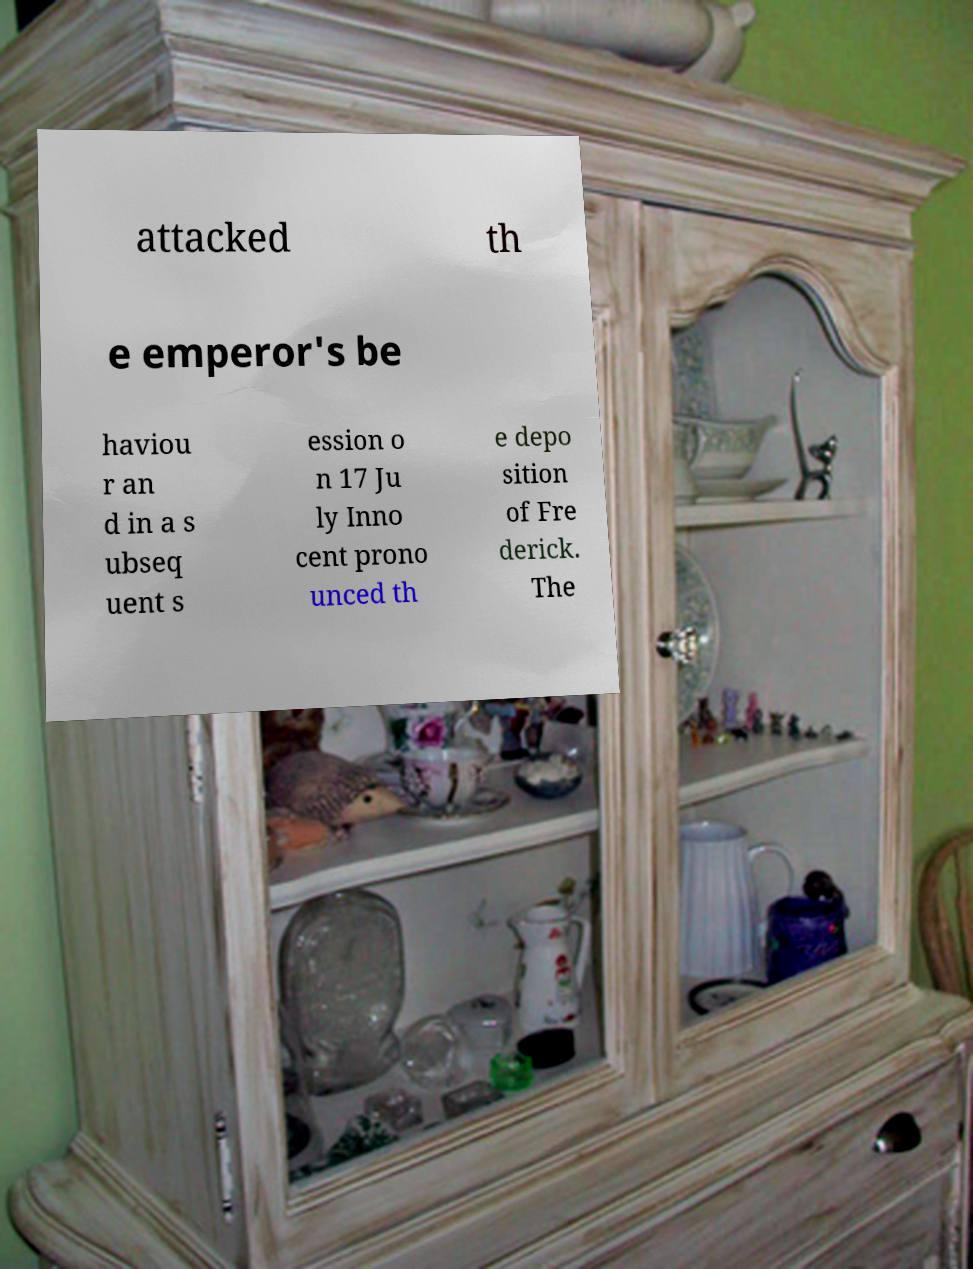Can you accurately transcribe the text from the provided image for me? attacked th e emperor's be haviou r an d in a s ubseq uent s ession o n 17 Ju ly Inno cent prono unced th e depo sition of Fre derick. The 